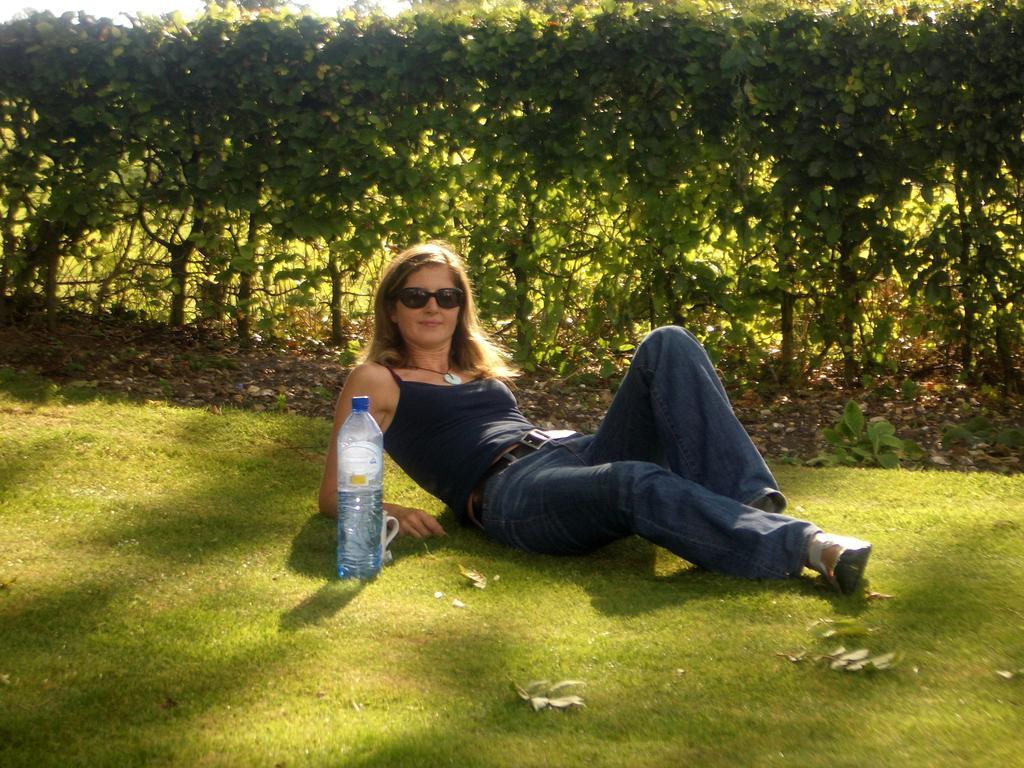Can you describe this image briefly? On the background we can see trees. These are dried leaves. We can see a plant hire. We can see a woman lying on a grass and she is carrying a smile on her face. She wore goggles. This is a water bottle and behind to the bottle we can see a cup. 